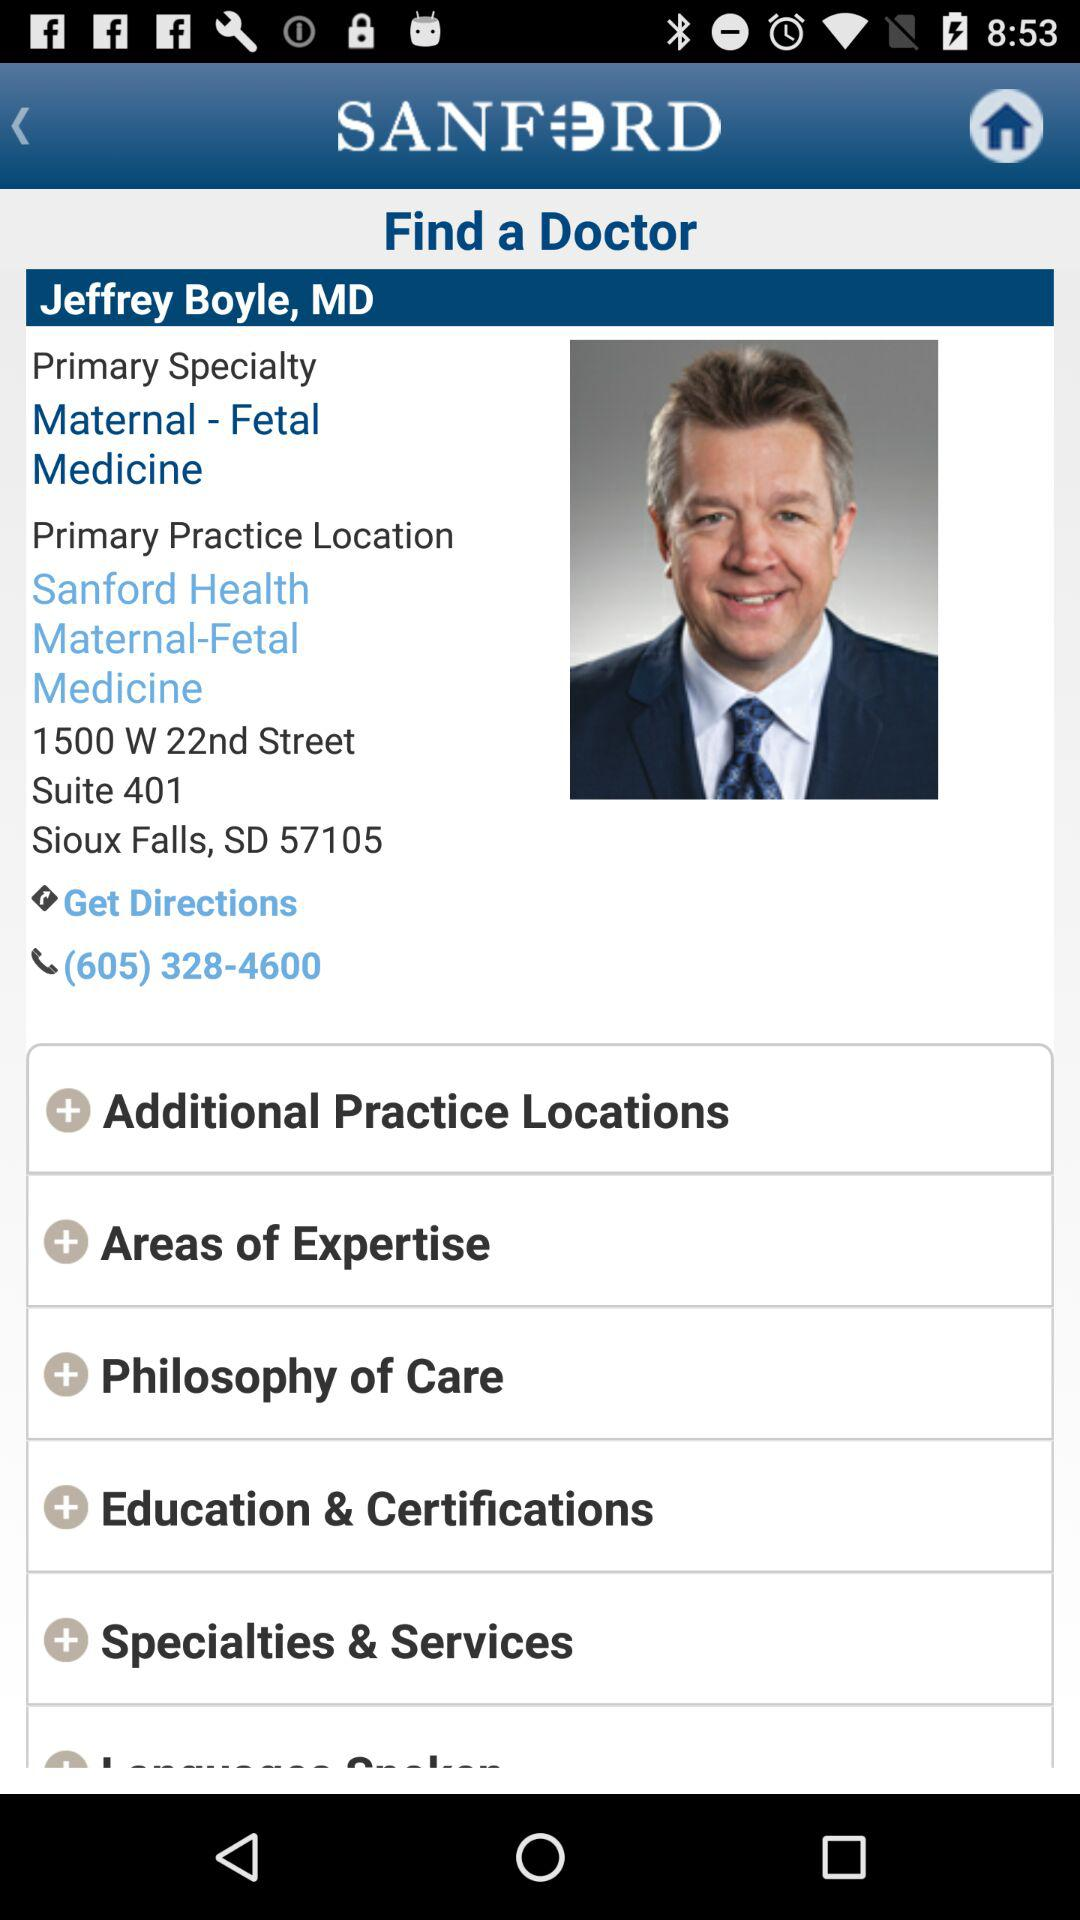What is the primary specialty? The primary specialty is maternal-fetal medicine. 